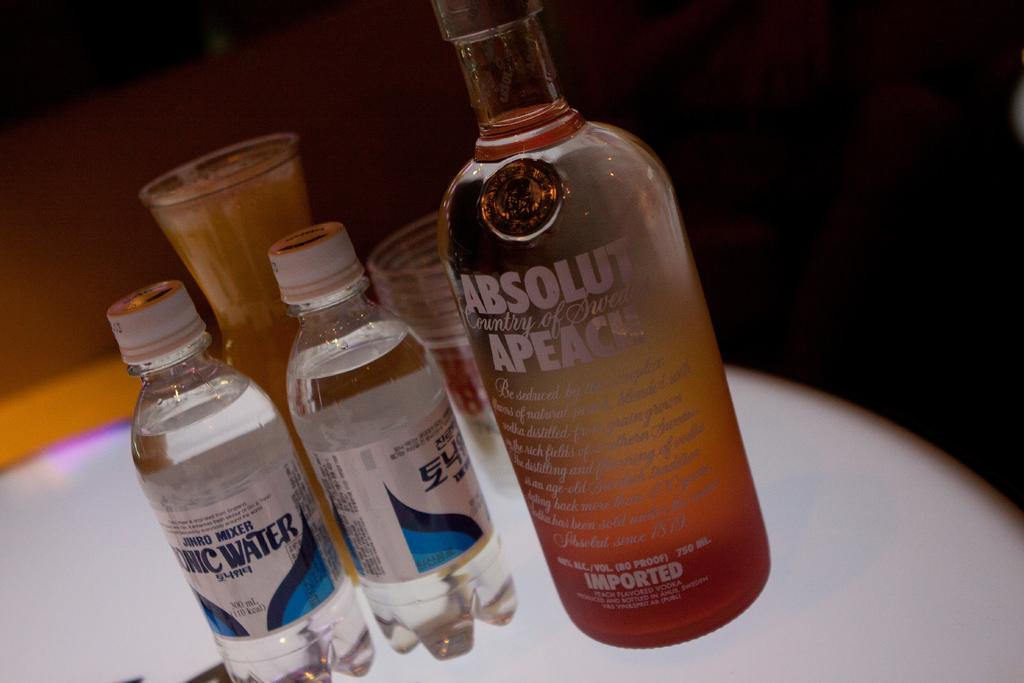Provide a one-sentence caption for the provided image. Absolut Peach Alcohol drink with two waters beside it. 